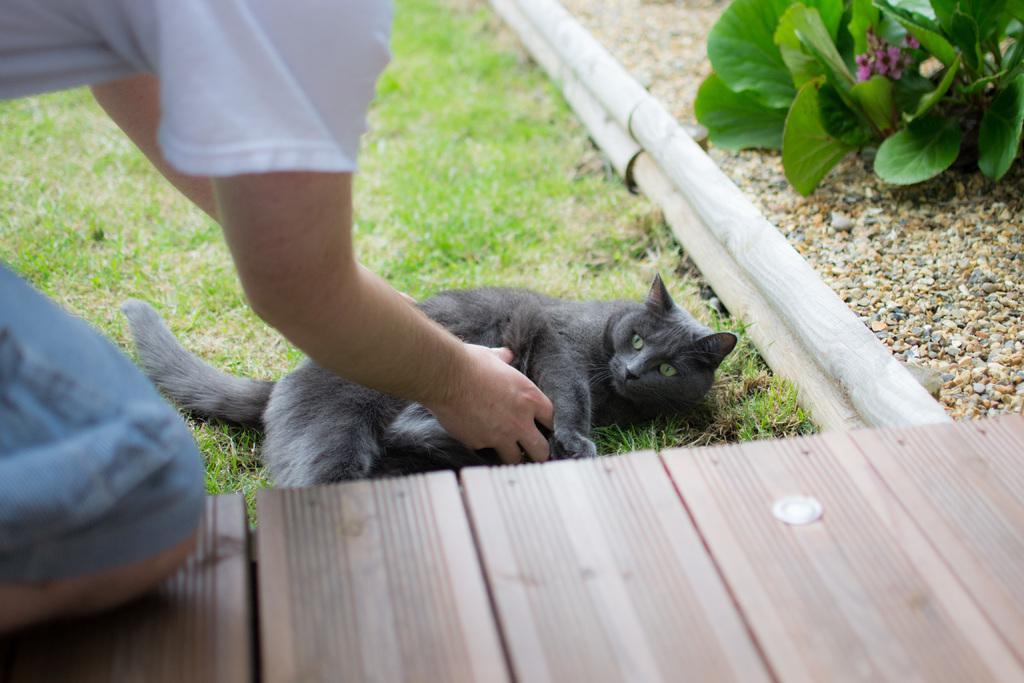Describe this image in one or two sentences. In the middle of the picture, we see a black cat. The man on the left side is trying to hold the cat with his hands. Beside that, we see the grass. At the bottom, we see a wooden floor or a bridge. In the right top, we see a plant which has flowers. These flowers are in pink color. Beside that, we see the wooden sticks and the stones. 